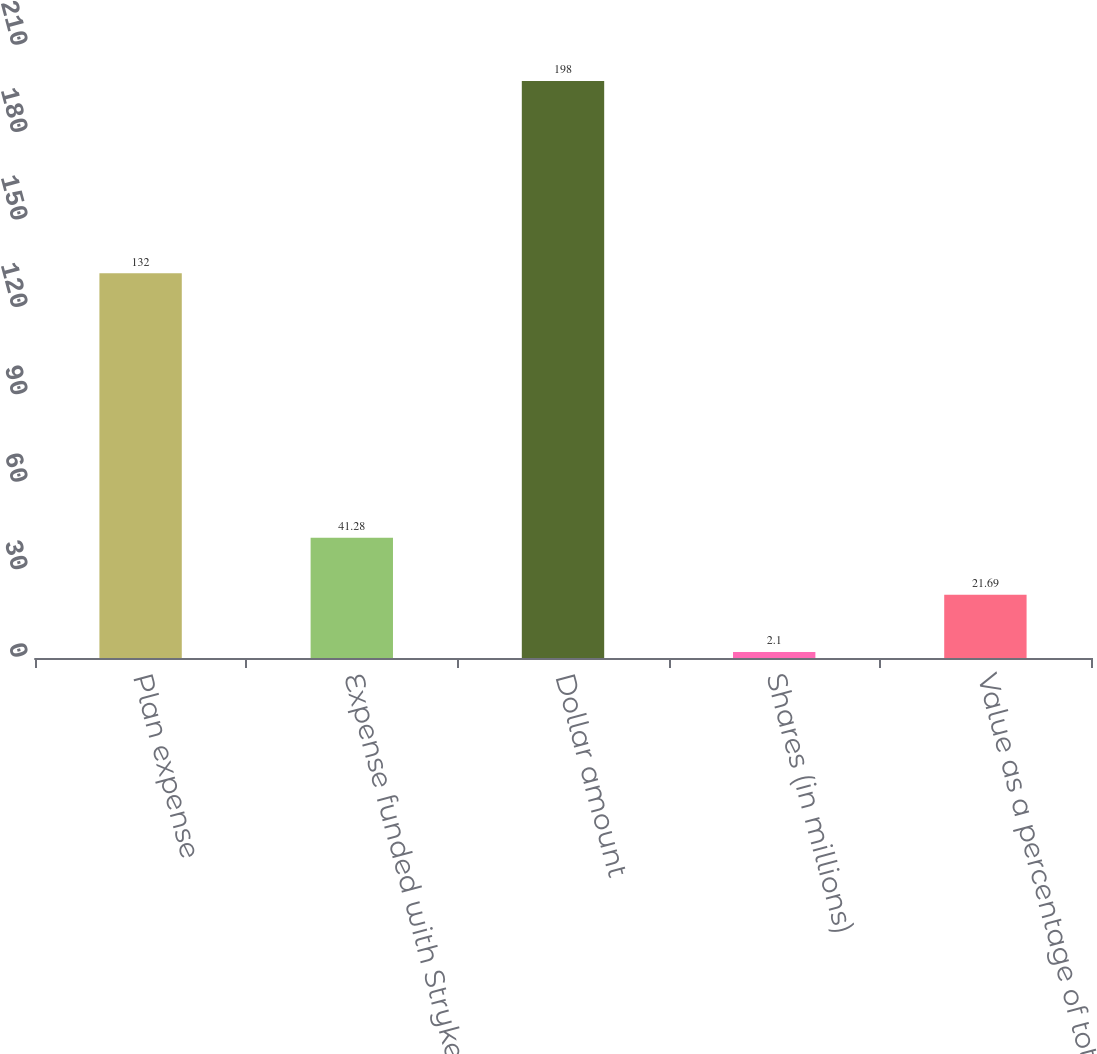Convert chart. <chart><loc_0><loc_0><loc_500><loc_500><bar_chart><fcel>Plan expense<fcel>Expense funded with Stryker<fcel>Dollar amount<fcel>Shares (in millions)<fcel>Value as a percentage of total<nl><fcel>132<fcel>41.28<fcel>198<fcel>2.1<fcel>21.69<nl></chart> 